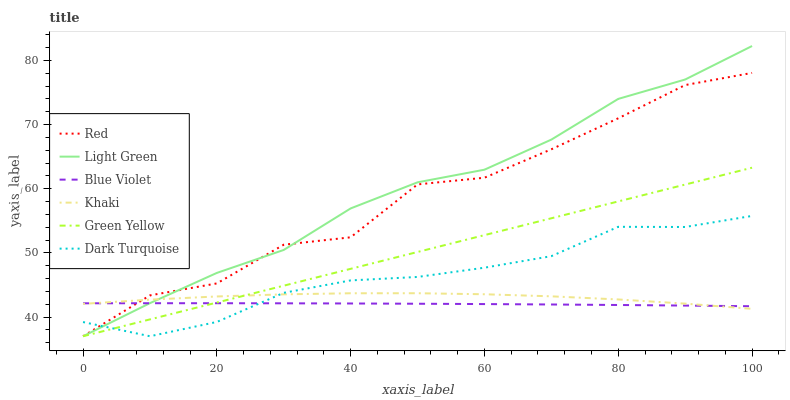Does Blue Violet have the minimum area under the curve?
Answer yes or no. Yes. Does Light Green have the maximum area under the curve?
Answer yes or no. Yes. Does Dark Turquoise have the minimum area under the curve?
Answer yes or no. No. Does Dark Turquoise have the maximum area under the curve?
Answer yes or no. No. Is Green Yellow the smoothest?
Answer yes or no. Yes. Is Red the roughest?
Answer yes or no. Yes. Is Dark Turquoise the smoothest?
Answer yes or no. No. Is Dark Turquoise the roughest?
Answer yes or no. No. Does Dark Turquoise have the lowest value?
Answer yes or no. Yes. Does Blue Violet have the lowest value?
Answer yes or no. No. Does Light Green have the highest value?
Answer yes or no. Yes. Does Dark Turquoise have the highest value?
Answer yes or no. No. Does Green Yellow intersect Khaki?
Answer yes or no. Yes. Is Green Yellow less than Khaki?
Answer yes or no. No. Is Green Yellow greater than Khaki?
Answer yes or no. No. 